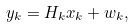<formula> <loc_0><loc_0><loc_500><loc_500>y _ { k } = H _ { k } x _ { k } + w _ { k } ,</formula> 